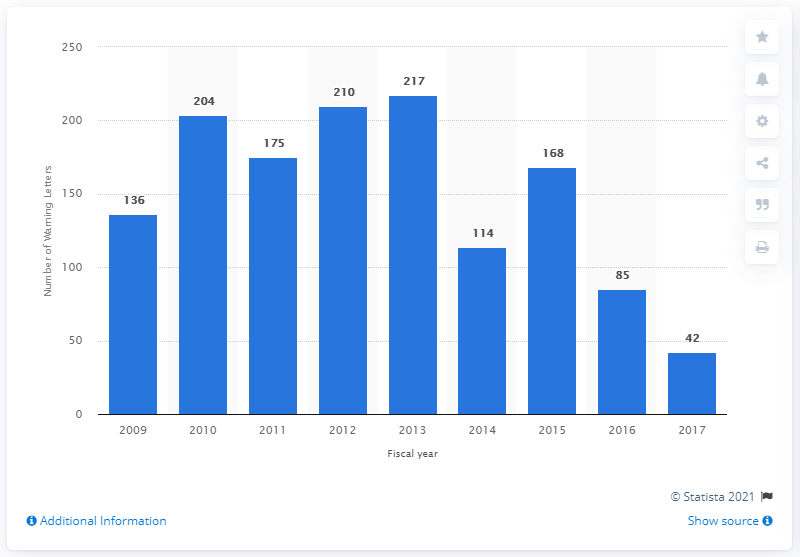Specify some key components in this picture. In 2015, the FDA sent 168 warning letters. 